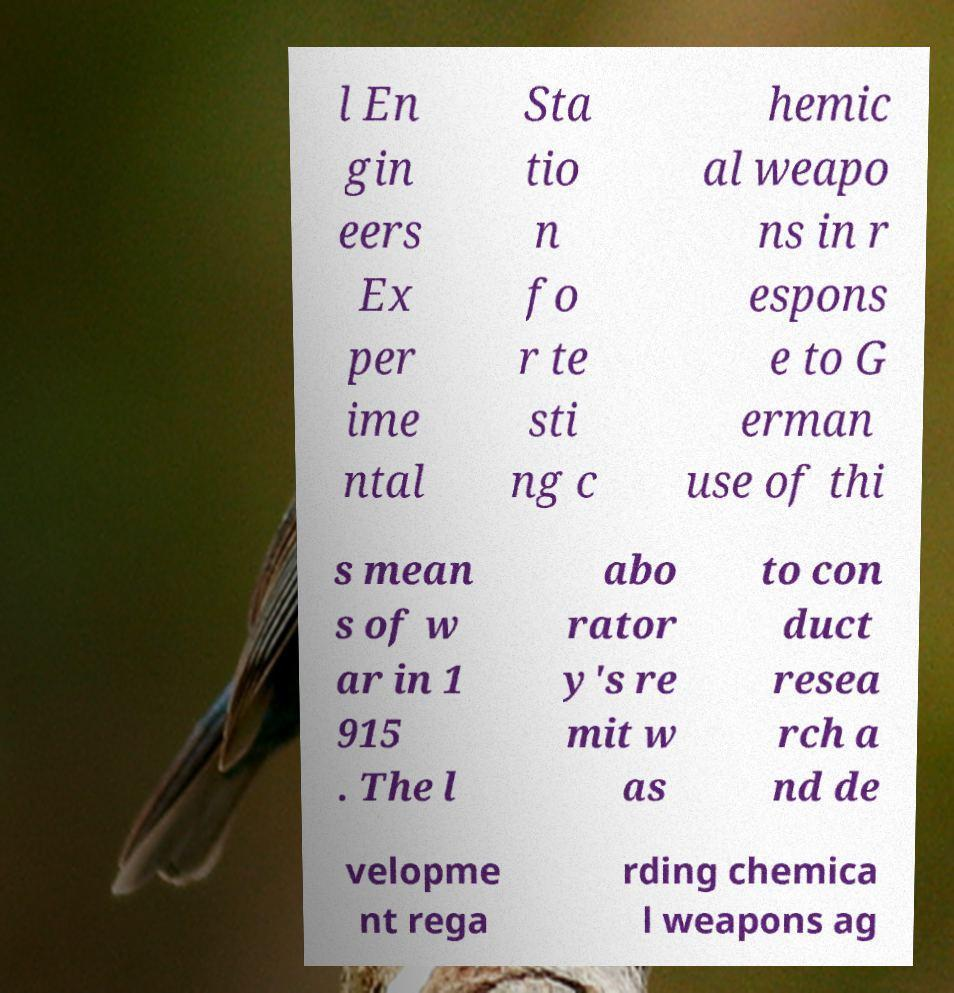Please read and relay the text visible in this image. What does it say? l En gin eers Ex per ime ntal Sta tio n fo r te sti ng c hemic al weapo ns in r espons e to G erman use of thi s mean s of w ar in 1 915 . The l abo rator y's re mit w as to con duct resea rch a nd de velopme nt rega rding chemica l weapons ag 